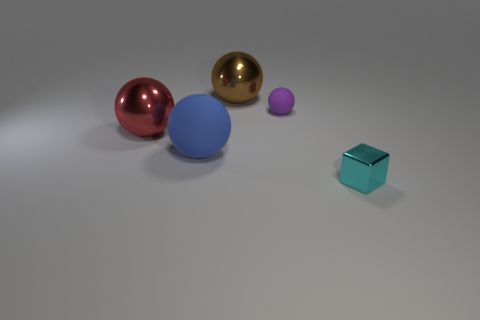Add 4 brown shiny spheres. How many objects exist? 9 Subtract all tiny balls. How many balls are left? 3 Subtract all brown spheres. How many spheres are left? 3 Subtract 0 green blocks. How many objects are left? 5 Subtract all balls. How many objects are left? 1 Subtract 1 cubes. How many cubes are left? 0 Subtract all blue blocks. Subtract all purple cylinders. How many blocks are left? 1 Subtract all green blocks. How many gray spheres are left? 0 Subtract all cyan metallic blocks. Subtract all big blue rubber spheres. How many objects are left? 3 Add 2 blocks. How many blocks are left? 3 